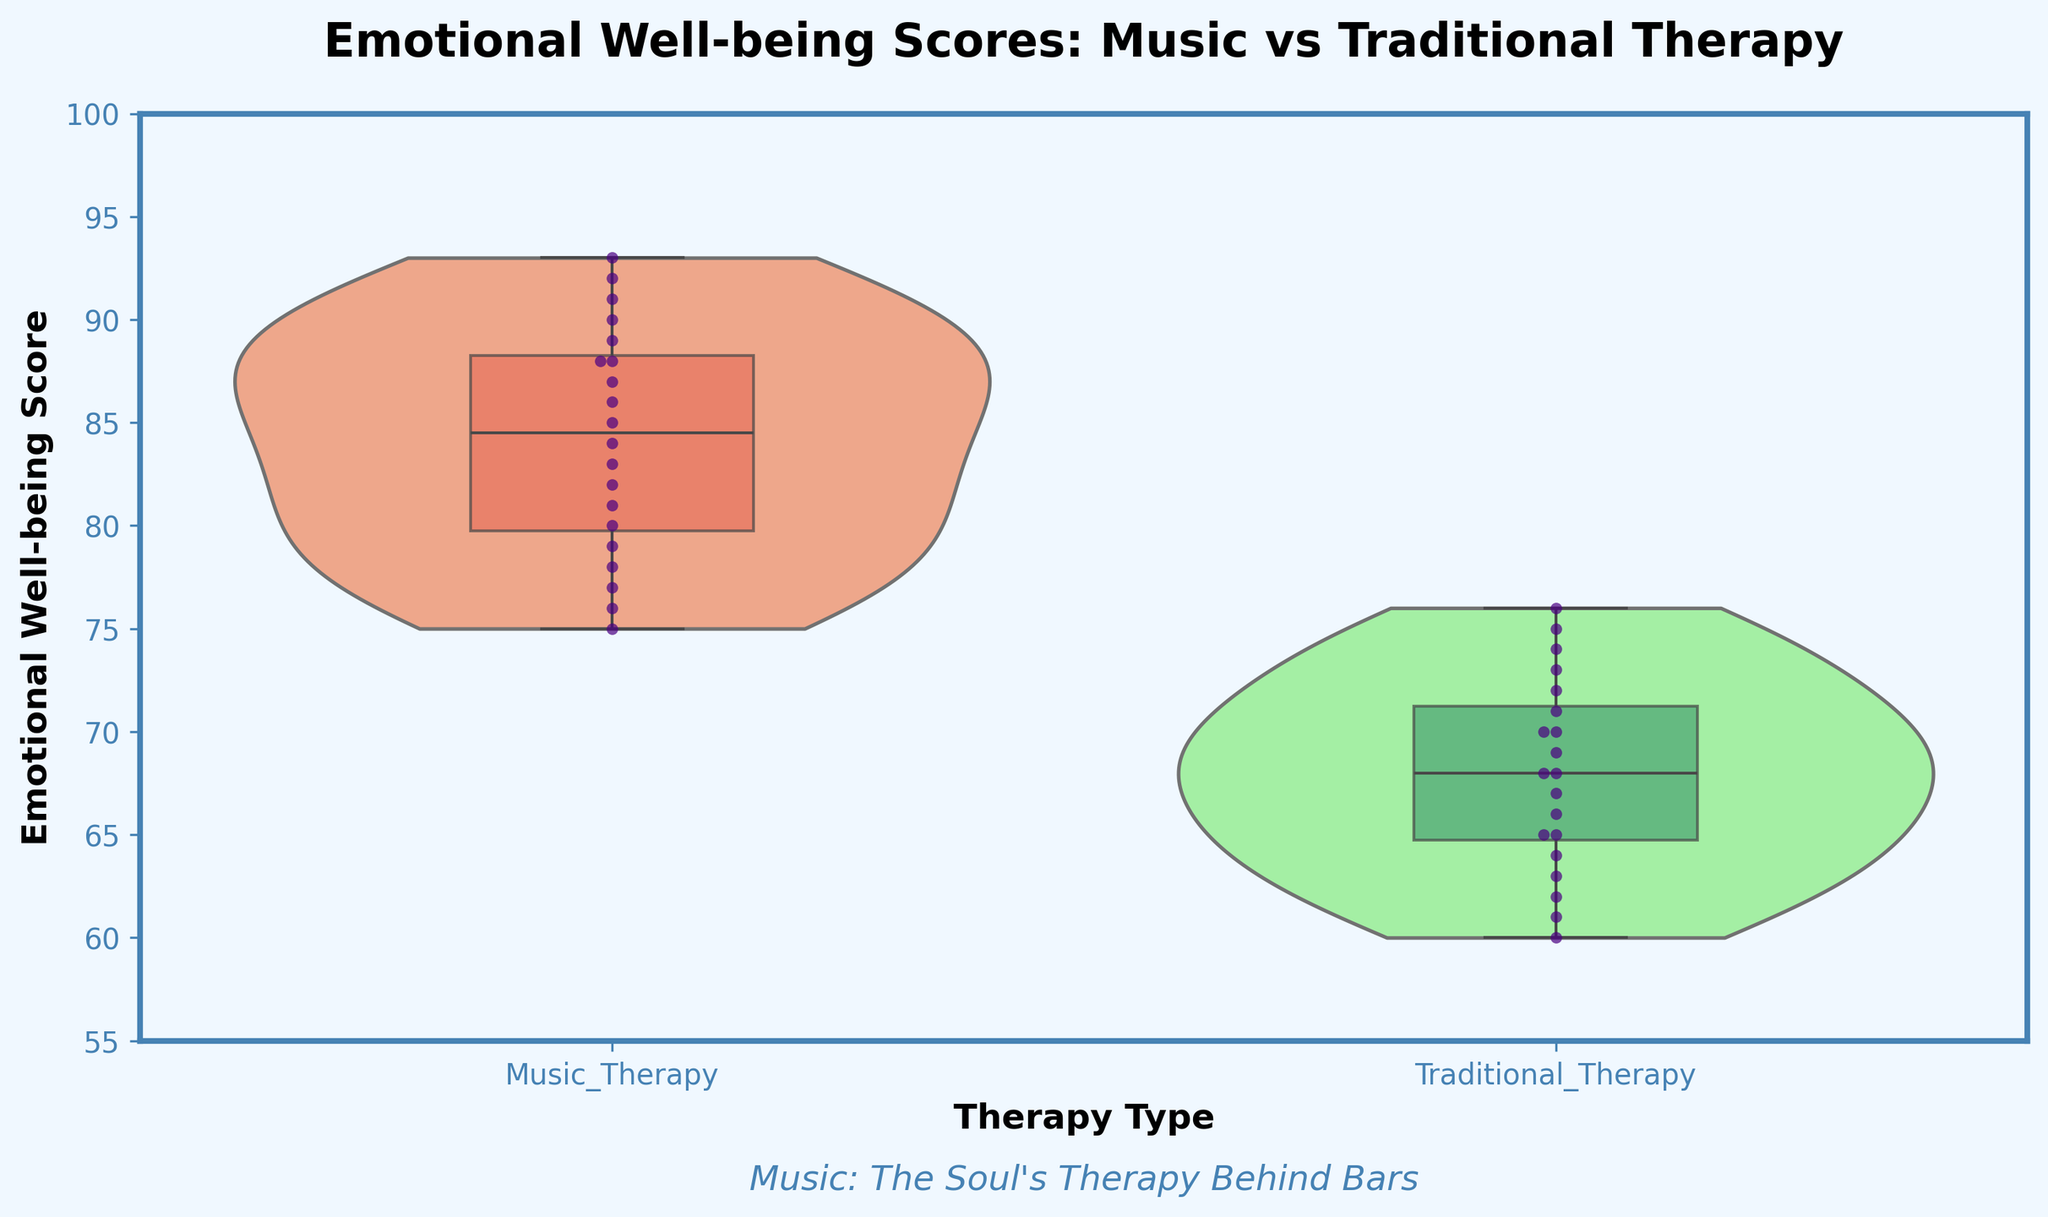What is the title of the figure? The title is located at the top of the figure and reads "Emotional Well-being Scores: Music vs Traditional Therapy".
Answer: Emotional Well-being Scores: Music vs Traditional Therapy Which color represents Music Therapy in the violin plot? The violin plot uses a distinct pale color for each therapy type, and for Music Therapy, it is a light orange shade.
Answer: Light orange What is the median Emotional Well-being Score for participants in Traditional Therapy? The median score is marked by the central line in the box plot overlay within the violin plot. For Traditional Therapy, it is located at 68.
Answer: 68 Are the Emotional Well-being Scores for Music Therapy higher overall compared to Traditional Therapy? By observing the violin plots and the box plots, Music Therapy scores are generally higher because the central tendency (median) and the interquartile range are positioned higher on the y-axis.
Answer: Yes What is the range of Emotional Well-being Scores for participants in Music Therapy? By examining the violin plot and box plot for Music Therapy, the scores range from about 75 to 93.
Answer: 75 to 93 How many outliers are there in the Traditional Therapy group? Outliers are typically not shown in the box plot overlay, and in this figure, outliers are not depicted as the boxplot is displayed without showing fliers.
Answer: 0 What does the inner line within each violin plot represent? The inner line within each violin plot represents the distribution of the data, giving a visual cue of the data density.
Answer: Data density Which therapy type shows a greater variability in Emotional Well-being Scores? Variability can be deduced by looking at the width and spread of the violin plots as well as the range in the box plots. The Music Therapy group appears to show slightly more spread and thus, greater variability.
Answer: Music Therapy Is there any overlapping in Emotional Well-being Scores between Music Therapy and Traditional Therapy? By observing the range of the scores in the violin plots, there is a noticeable range of overlapping scores from approximately 75 to 76.
Answer: Yes What additional text is present below the x-axis labels? Under the x-axis, an italicized text "Music: The Soul's Therapy Behind Bars" is presented, providing a contextual note about the significance of music therapy.
Answer: Music: The Soul's Therapy Behind Bars 